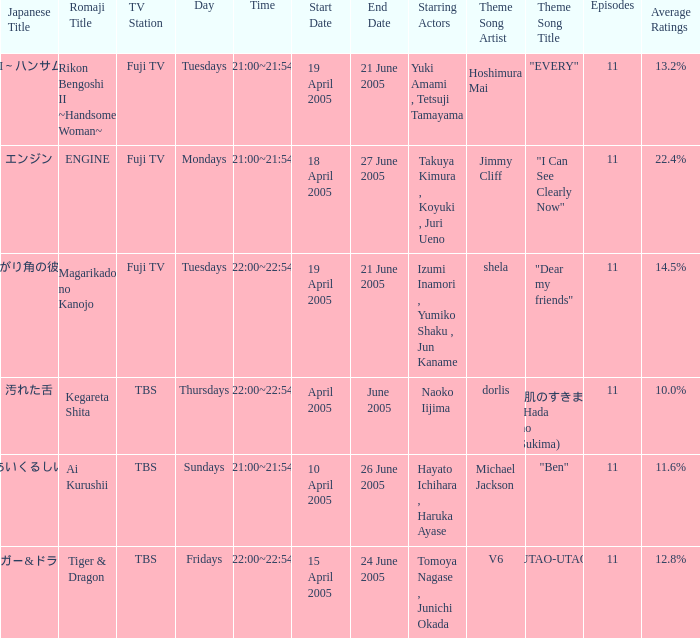What is the theme song for Magarikado no Kanojo? Shela "dear my friends". 